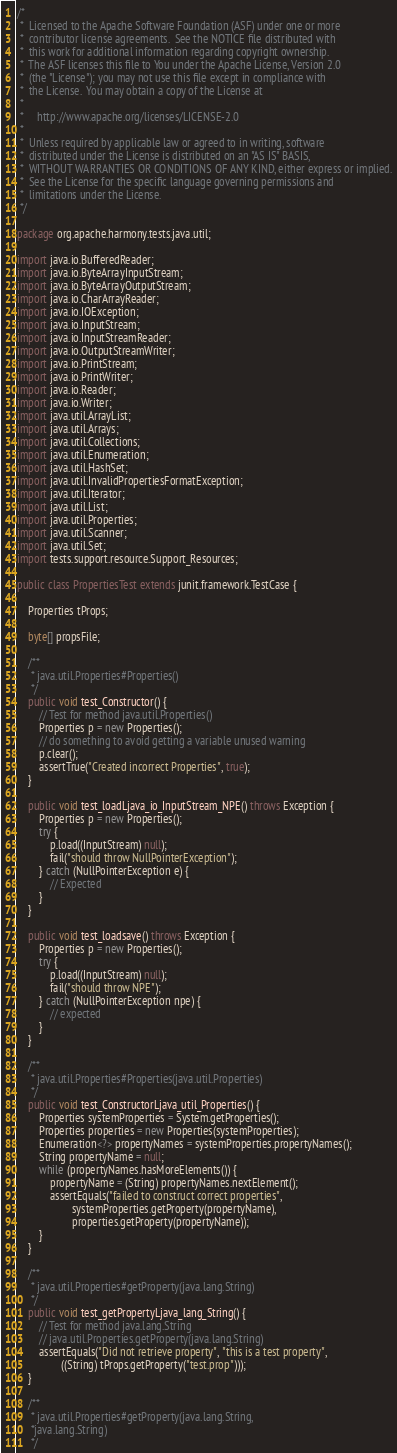<code> <loc_0><loc_0><loc_500><loc_500><_Java_>/*
 *  Licensed to the Apache Software Foundation (ASF) under one or more
 *  contributor license agreements.  See the NOTICE file distributed with
 *  this work for additional information regarding copyright ownership.
 *  The ASF licenses this file to You under the Apache License, Version 2.0
 *  (the "License"); you may not use this file except in compliance with
 *  the License.  You may obtain a copy of the License at
 *
 *     http://www.apache.org/licenses/LICENSE-2.0
 *
 *  Unless required by applicable law or agreed to in writing, software
 *  distributed under the License is distributed on an "AS IS" BASIS,
 *  WITHOUT WARRANTIES OR CONDITIONS OF ANY KIND, either express or implied.
 *  See the License for the specific language governing permissions and
 *  limitations under the License.
 */

package org.apache.harmony.tests.java.util;

import java.io.BufferedReader;
import java.io.ByteArrayInputStream;
import java.io.ByteArrayOutputStream;
import java.io.CharArrayReader;
import java.io.IOException;
import java.io.InputStream;
import java.io.InputStreamReader;
import java.io.OutputStreamWriter;
import java.io.PrintStream;
import java.io.PrintWriter;
import java.io.Reader;
import java.io.Writer;
import java.util.ArrayList;
import java.util.Arrays;
import java.util.Collections;
import java.util.Enumeration;
import java.util.HashSet;
import java.util.InvalidPropertiesFormatException;
import java.util.Iterator;
import java.util.List;
import java.util.Properties;
import java.util.Scanner;
import java.util.Set;
import tests.support.resource.Support_Resources;

public class PropertiesTest extends junit.framework.TestCase {

    Properties tProps;

    byte[] propsFile;

    /**
     * java.util.Properties#Properties()
     */
    public void test_Constructor() {
        // Test for method java.util.Properties()
        Properties p = new Properties();
        // do something to avoid getting a variable unused warning
        p.clear();
        assertTrue("Created incorrect Properties", true);
    }

    public void test_loadLjava_io_InputStream_NPE() throws Exception {
        Properties p = new Properties();
        try {
            p.load((InputStream) null);
            fail("should throw NullPointerException");
        } catch (NullPointerException e) {
            // Expected
        }
    }

    public void test_loadsave() throws Exception {
        Properties p = new Properties();
        try {
            p.load((InputStream) null);
            fail("should throw NPE");
        } catch (NullPointerException npe) {
            // expected
        }
    }

    /**
     * java.util.Properties#Properties(java.util.Properties)
     */
    public void test_ConstructorLjava_util_Properties() {
        Properties systemProperties = System.getProperties();
        Properties properties = new Properties(systemProperties);
        Enumeration<?> propertyNames = systemProperties.propertyNames();
        String propertyName = null;
        while (propertyNames.hasMoreElements()) {
            propertyName = (String) propertyNames.nextElement();
            assertEquals("failed to construct correct properties",
                    systemProperties.getProperty(propertyName),
                    properties.getProperty(propertyName));
        }
    }

    /**
     * java.util.Properties#getProperty(java.lang.String)
     */
    public void test_getPropertyLjava_lang_String() {
        // Test for method java.lang.String
        // java.util.Properties.getProperty(java.lang.String)
        assertEquals("Did not retrieve property", "this is a test property",
                ((String) tProps.getProperty("test.prop")));
    }

    /**
     * java.util.Properties#getProperty(java.lang.String,
     *java.lang.String)
     */</code> 